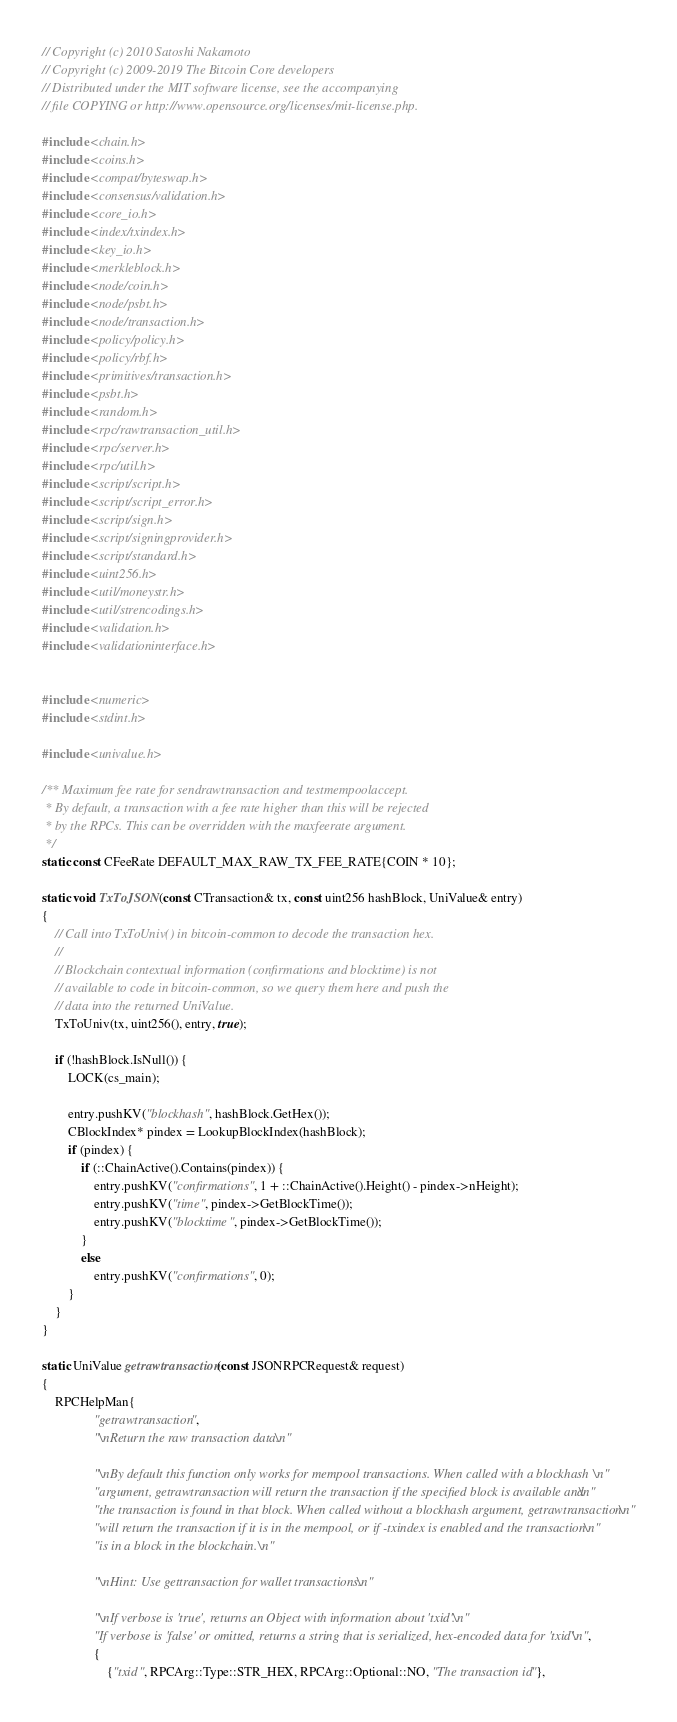<code> <loc_0><loc_0><loc_500><loc_500><_C++_>// Copyright (c) 2010 Satoshi Nakamoto
// Copyright (c) 2009-2019 The Bitcoin Core developers
// Distributed under the MIT software license, see the accompanying
// file COPYING or http://www.opensource.org/licenses/mit-license.php.

#include <chain.h>
#include <coins.h>
#include <compat/byteswap.h>
#include <consensus/validation.h>
#include <core_io.h>
#include <index/txindex.h>
#include <key_io.h>
#include <merkleblock.h>
#include <node/coin.h>
#include <node/psbt.h>
#include <node/transaction.h>
#include <policy/policy.h>
#include <policy/rbf.h>
#include <primitives/transaction.h>
#include <psbt.h>
#include <random.h>
#include <rpc/rawtransaction_util.h>
#include <rpc/server.h>
#include <rpc/util.h>
#include <script/script.h>
#include <script/script_error.h>
#include <script/sign.h>
#include <script/signingprovider.h>
#include <script/standard.h>
#include <uint256.h>
#include <util/moneystr.h>
#include <util/strencodings.h>
#include <validation.h>
#include <validationinterface.h>


#include <numeric>
#include <stdint.h>

#include <univalue.h>

/** Maximum fee rate for sendrawtransaction and testmempoolaccept.
 * By default, a transaction with a fee rate higher than this will be rejected
 * by the RPCs. This can be overridden with the maxfeerate argument.
 */
static const CFeeRate DEFAULT_MAX_RAW_TX_FEE_RATE{COIN * 10};

static void TxToJSON(const CTransaction& tx, const uint256 hashBlock, UniValue& entry)
{
    // Call into TxToUniv() in bitcoin-common to decode the transaction hex.
    //
    // Blockchain contextual information (confirmations and blocktime) is not
    // available to code in bitcoin-common, so we query them here and push the
    // data into the returned UniValue.
    TxToUniv(tx, uint256(), entry, true);

    if (!hashBlock.IsNull()) {
        LOCK(cs_main);

        entry.pushKV("blockhash", hashBlock.GetHex());
        CBlockIndex* pindex = LookupBlockIndex(hashBlock);
        if (pindex) {
            if (::ChainActive().Contains(pindex)) {
                entry.pushKV("confirmations", 1 + ::ChainActive().Height() - pindex->nHeight);
                entry.pushKV("time", pindex->GetBlockTime());
                entry.pushKV("blocktime", pindex->GetBlockTime());
            }
            else
                entry.pushKV("confirmations", 0);
        }
    }
}

static UniValue getrawtransaction(const JSONRPCRequest& request)
{
    RPCHelpMan{
                "getrawtransaction",
                "\nReturn the raw transaction data.\n"

                "\nBy default this function only works for mempool transactions. When called with a blockhash\n"
                "argument, getrawtransaction will return the transaction if the specified block is available and\n"
                "the transaction is found in that block. When called without a blockhash argument, getrawtransaction\n"
                "will return the transaction if it is in the mempool, or if -txindex is enabled and the transaction\n"
                "is in a block in the blockchain.\n"

                "\nHint: Use gettransaction for wallet transactions.\n"

                "\nIf verbose is 'true', returns an Object with information about 'txid'.\n"
                "If verbose is 'false' or omitted, returns a string that is serialized, hex-encoded data for 'txid'.\n",
                {
                    {"txid", RPCArg::Type::STR_HEX, RPCArg::Optional::NO, "The transaction id"},</code> 